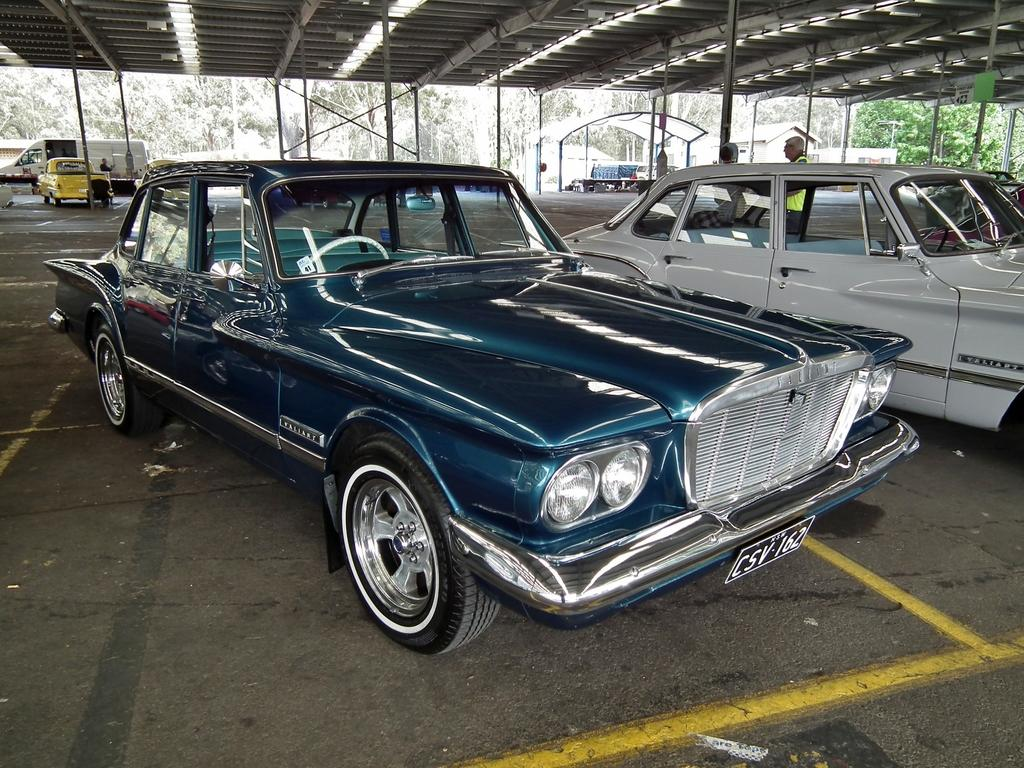What type of structure is visible in the image? There is an open shed in the image. What is located under the shed? There are vehicles with number plates and people present under the shed. What can be seen in the background of the image? There are trees and vehicles in the background of the image. Where is the throne located in the image? There is no throne present in the image. Can you describe the fog in the image? There is no fog present in the image. 